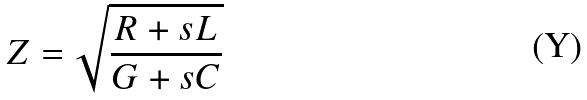Convert formula to latex. <formula><loc_0><loc_0><loc_500><loc_500>Z = \sqrt { \frac { R + s L } { G + s C } }</formula> 